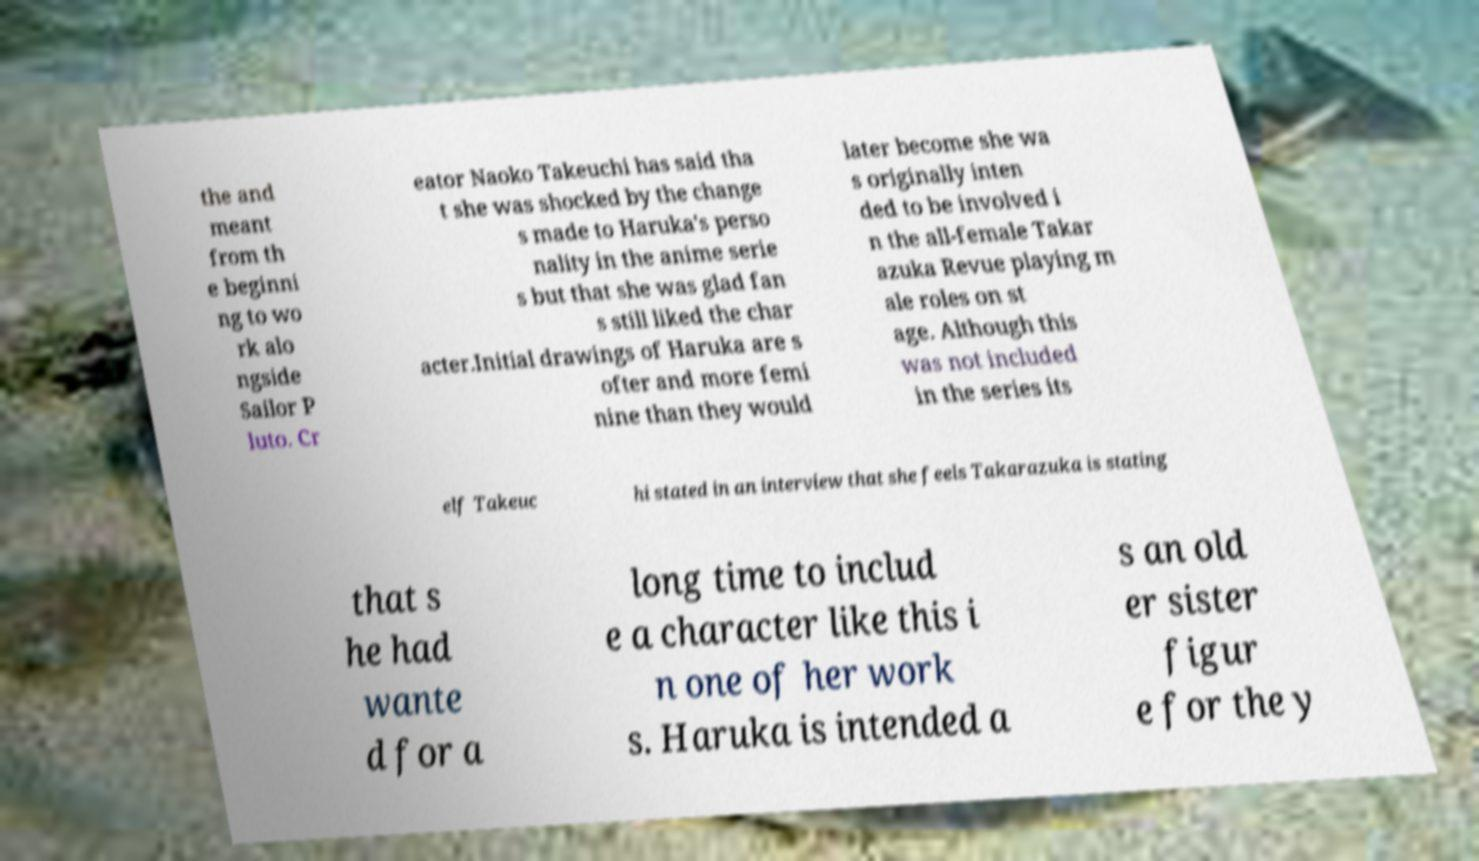Could you extract and type out the text from this image? the and meant from th e beginni ng to wo rk alo ngside Sailor P luto. Cr eator Naoko Takeuchi has said tha t she was shocked by the change s made to Haruka's perso nality in the anime serie s but that she was glad fan s still liked the char acter.Initial drawings of Haruka are s ofter and more femi nine than they would later become she wa s originally inten ded to be involved i n the all-female Takar azuka Revue playing m ale roles on st age. Although this was not included in the series its elf Takeuc hi stated in an interview that she feels Takarazuka is stating that s he had wante d for a long time to includ e a character like this i n one of her work s. Haruka is intended a s an old er sister figur e for the y 